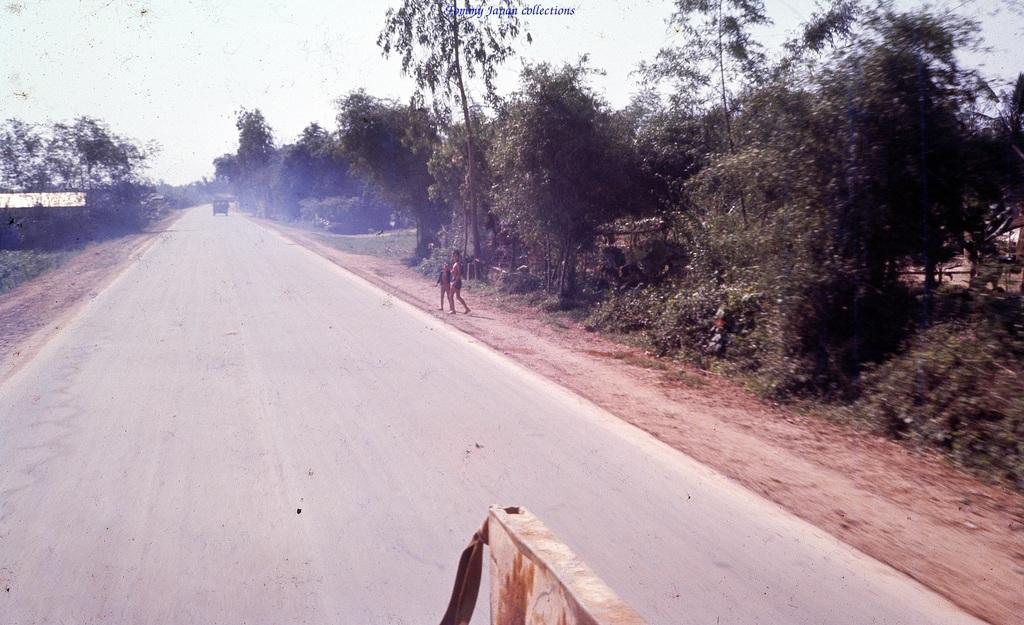How would you summarize this image in a sentence or two? In this picture we can see couple of people, they are standing beside the road and we can find a vehicle on the road, on the left and right hand side of the image we can see few trees. 